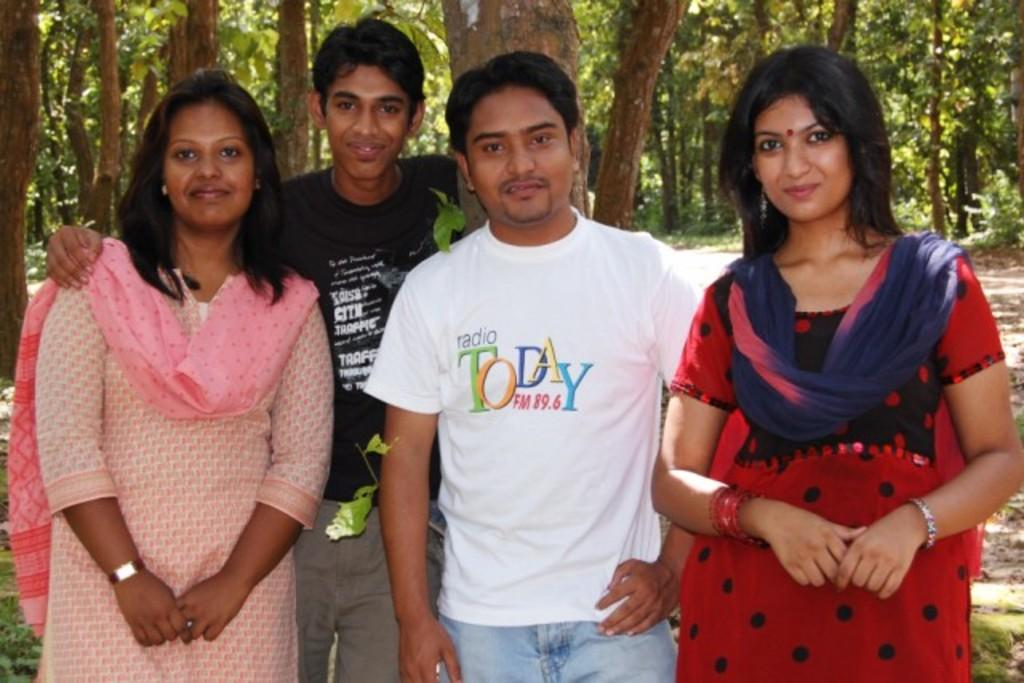How many people are present in the image? There are four people in the image. What can be observed about the clothing of the people in the image? The people are wearing different color dresses. What is visible in the background of the image? There are many trees in the background of the image. What type of apple is being discussed by the people in the image? There is no apple present in the image, nor is there any indication that the people are discussing one. Is there a writer in the image? There is no mention of a writer or any writing activity in the image. 